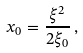Convert formula to latex. <formula><loc_0><loc_0><loc_500><loc_500>x _ { 0 } = \frac { \xi ^ { 2 } } { 2 \xi _ { 0 } } \, ,</formula> 